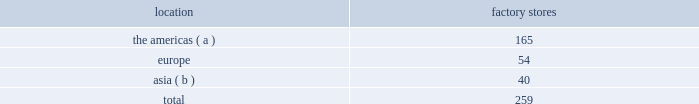Factory stores we extend our reach to additional consumer groups through our 259 factory stores worldwide , which are principally located in major outlet centers .
During fiscal 2015 , we added 30 new factory stores and closed six factory stores .
We operated the following factory stores as of march 28 , 2015: .
( a ) includes the u.s .
And canada .
( b ) includes australia .
Our worldwide factory stores offer selections of our apparel , accessories , and fragrances .
In addition to these product offerings , certain of our factory stores in the americas offer home furnishings .
Our factory stores range in size from approximately 800 to 26700 square feet .
Factory stores obtain products from our suppliers , our product licensing partners , and our other retail stores and e-commerce operations , and also serve as a secondary distribution channel for our excess and out-of-season products .
Concession-based shop-within-shops the terms of trade for shop-within-shops are largely conducted on a concession basis , whereby inventory continues to be owned by us ( not the department store ) until ultimate sale to the end consumer .
The salespeople involved in the sales transactions are generally our employees and not those of the department store .
As of march 28 , 2015 , we had 536 concession-based shop-within-shops at 236 retail locations dedicated to our products , which were located in asia , australia , new zealand , and europe .
The size of our concession-based shop-within-shops ranges from approximately 200 to 6000 square feet .
We may share in the cost of building out certain of these shop-within-shops with our department store partners .
E-commerce websites in addition to our stores , our retail segment sells products online through our e-commerce channel , which includes : 2022 our north american e-commerce sites located at www.ralphlauren.com and www.clubmonaco.com , as well as our club monaco site in canada located at www.clubmonaco.ca ; 2022 our ralph lauren e-commerce sites in europe , including www.ralphlauren.co.uk ( servicing the united kingdom ) , www.ralphlauren.fr ( servicing belgium , france , italy , luxembourg , the netherlands , portugal , and spain ) , and www.ralphlauren.de ( recently expanded to service denmark , estonia , finland , latvia , slovakia , and sweden , in addition to servicing austria and germany ) ; and 2022 our ralph lauren e-commerce sites in asia , including www.ralphlauren.co.jp ( servicing japan ) , www.ralphlauren.co.kr ( servicing south korea ) , www.ralphlauren.asia ( servicing hong kong , macau , malaysia , and singapore ) , and www.ralphlauren.com.au ( servicing australia and new zealand ) .
Our ralph lauren e-commerce sites in the u.s. , europe , and asia offer our customers access to a broad array of ralph lauren , double rl , polo , and denim & supply apparel , accessories , fragrance , and home products , and reinforce the luxury image of our brands .
While investing in e-commerce operations remains a primary focus , it is an extension of our investment in the integrated omni-channel strategy used to operate our overall retail business , in which our e-commerce operations are interdependent with our physical stores .
Our club monaco e-commerce sites in the u.s .
And canada offer our domestic and canadian customers access to our global assortment of club monaco apparel and accessories product lines , as well as select online exclusives. .
What percentage of factory stores as of march 28 , 2015 where located in europe? 
Computations: (54 / 259)
Answer: 0.20849. 